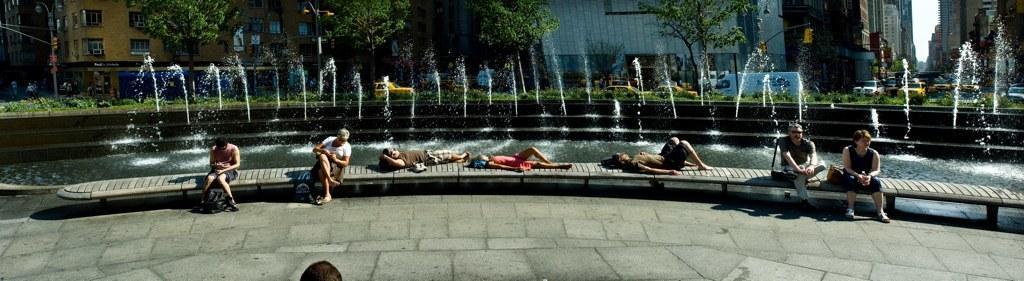Describe this image in one or two sentences. In this image I see few people who are siting and these 3 are lying on this thing and I see the path. In the background I see the water and fountains over here and I see the vehicles, traffic signals, buildings and the trees. 